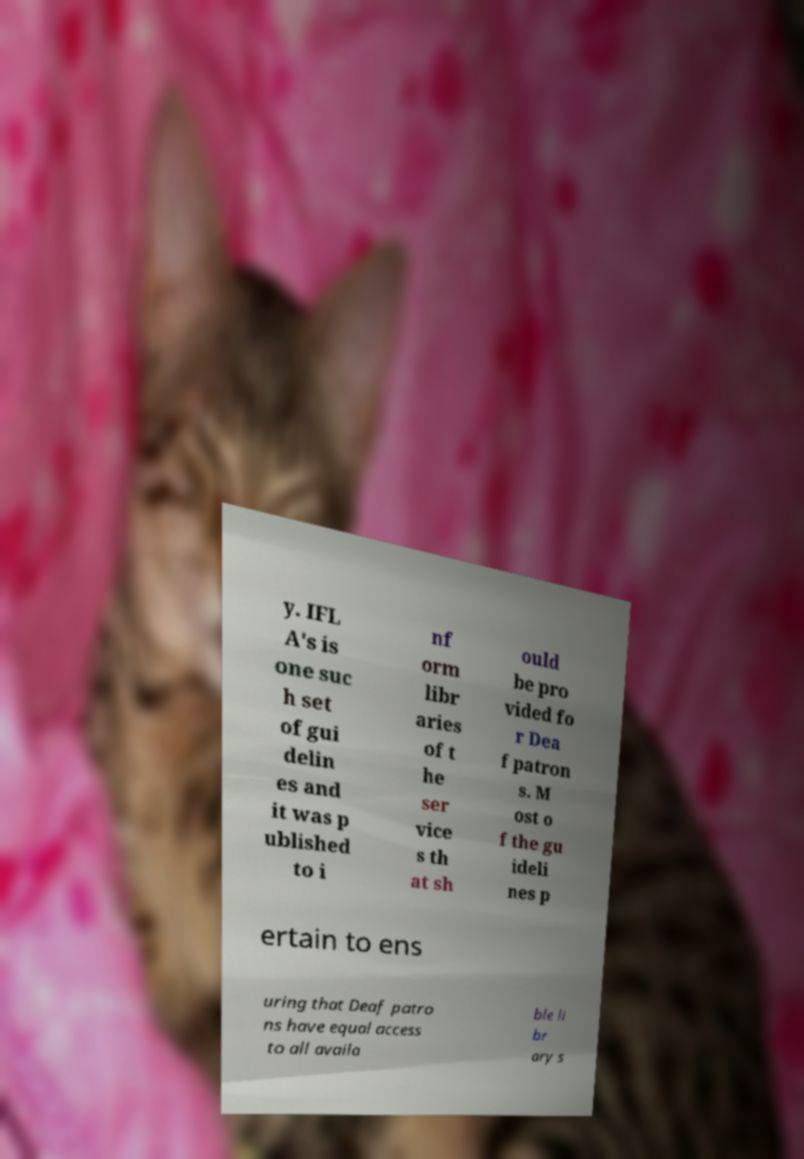Could you assist in decoding the text presented in this image and type it out clearly? y. IFL A's is one suc h set of gui delin es and it was p ublished to i nf orm libr aries of t he ser vice s th at sh ould be pro vided fo r Dea f patron s. M ost o f the gu ideli nes p ertain to ens uring that Deaf patro ns have equal access to all availa ble li br ary s 